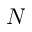<formula> <loc_0><loc_0><loc_500><loc_500>N</formula> 